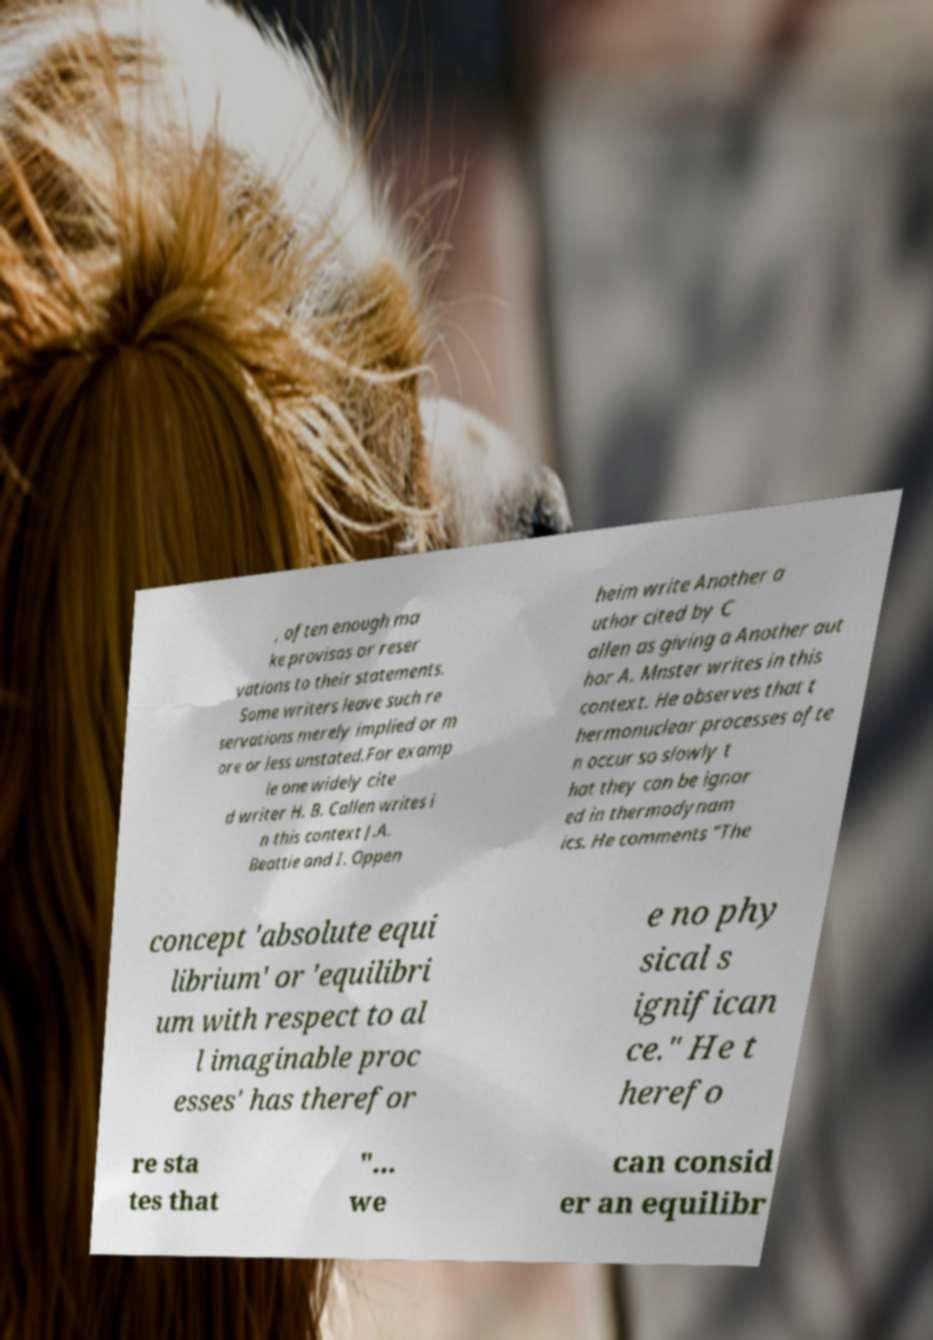There's text embedded in this image that I need extracted. Can you transcribe it verbatim? , often enough ma ke provisos or reser vations to their statements. Some writers leave such re servations merely implied or m ore or less unstated.For examp le one widely cite d writer H. B. Callen writes i n this context J.A. Beattie and I. Oppen heim write Another a uthor cited by C allen as giving a Another aut hor A. Mnster writes in this context. He observes that t hermonuclear processes ofte n occur so slowly t hat they can be ignor ed in thermodynam ics. He comments "The concept 'absolute equi librium' or 'equilibri um with respect to al l imaginable proc esses' has therefor e no phy sical s ignifican ce." He t herefo re sta tes that "... we can consid er an equilibr 